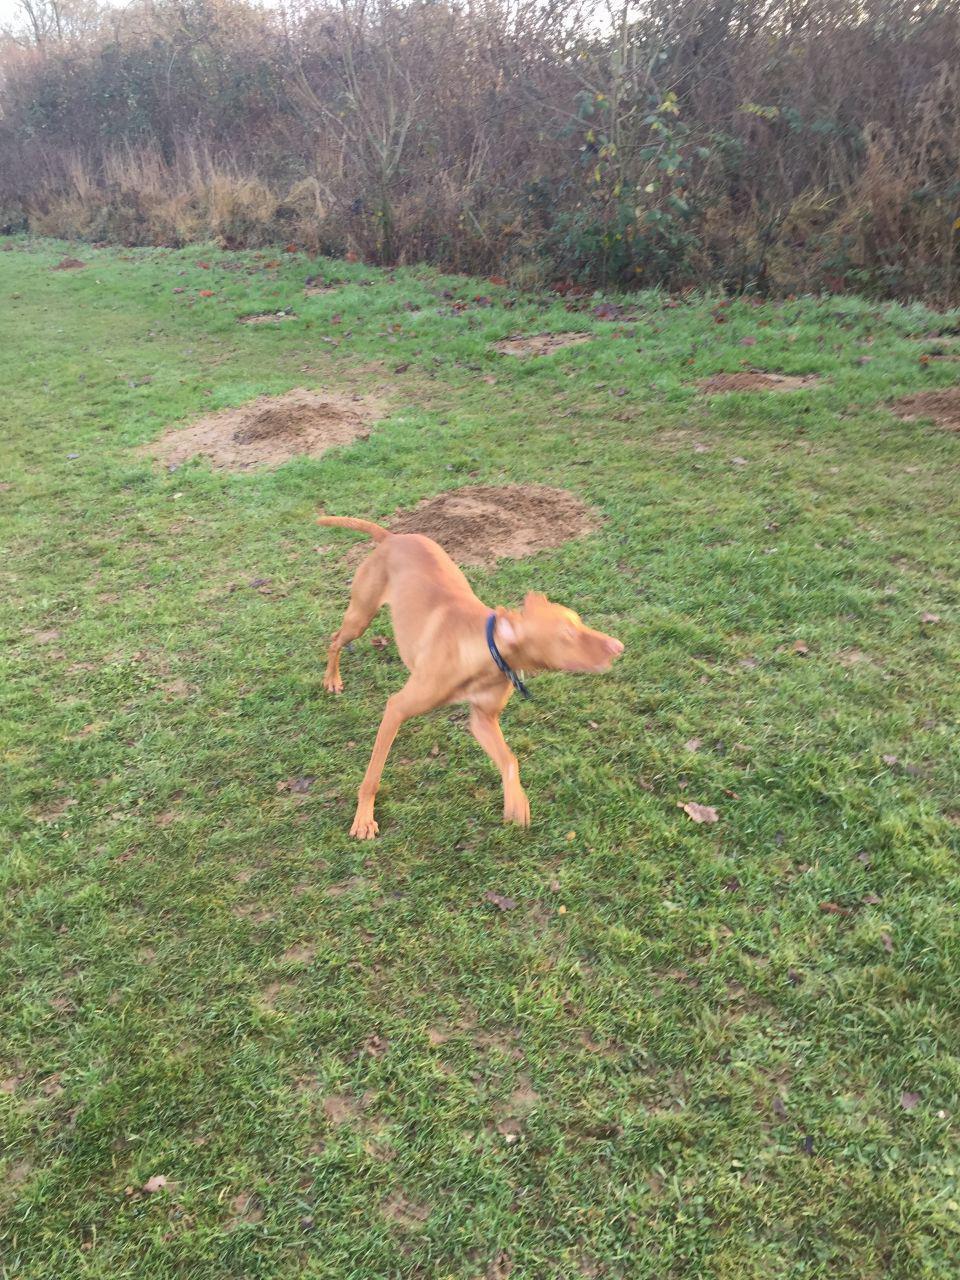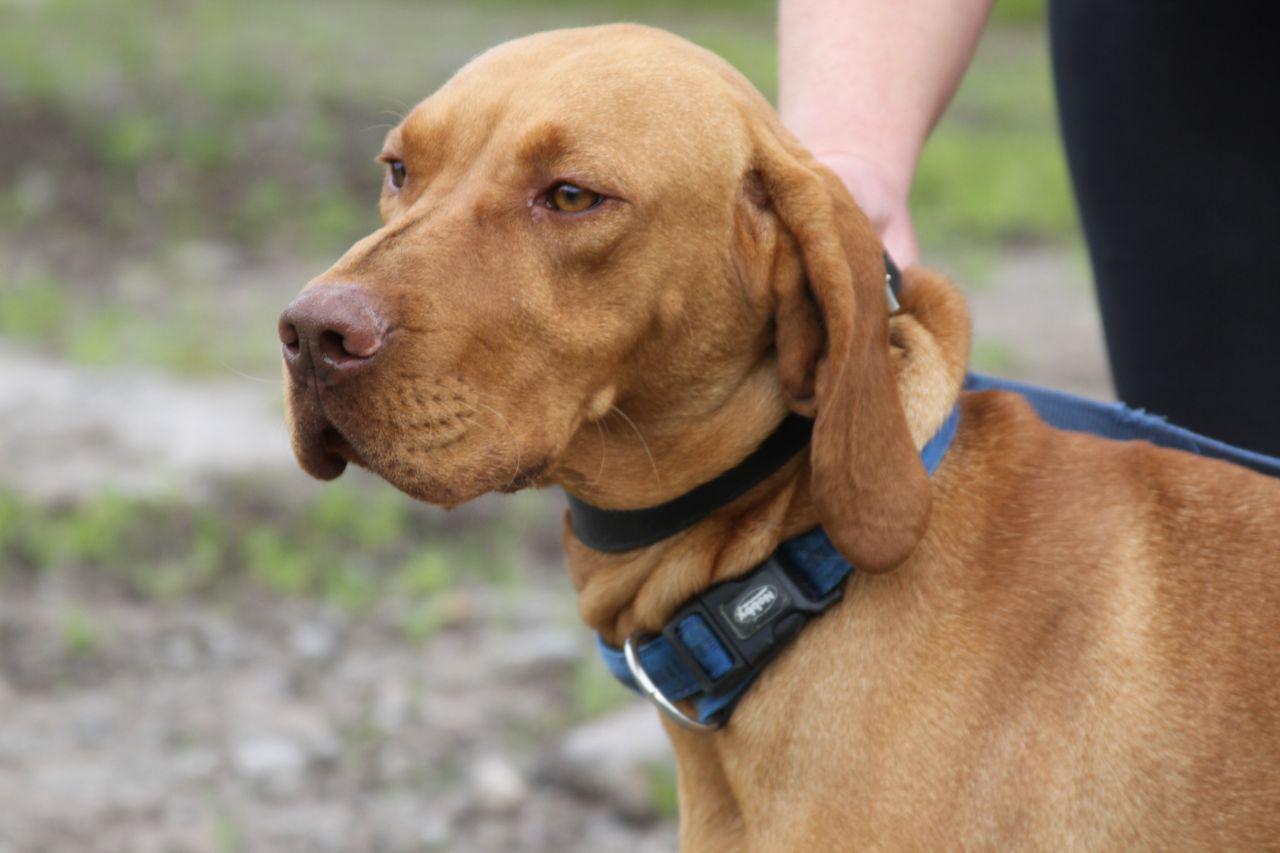The first image is the image on the left, the second image is the image on the right. Considering the images on both sides, is "An image shows two red-orange dogs and a bike rider going down the same path." valid? Answer yes or no. No. The first image is the image on the left, the second image is the image on the right. Given the left and right images, does the statement "One person is riding a bicycle near two dogs." hold true? Answer yes or no. No. 